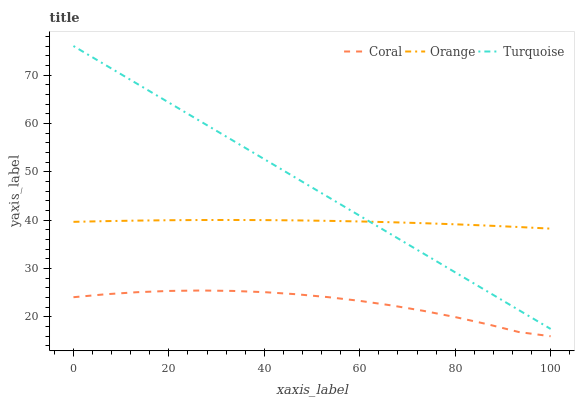Does Coral have the minimum area under the curve?
Answer yes or no. Yes. Does Turquoise have the maximum area under the curve?
Answer yes or no. Yes. Does Turquoise have the minimum area under the curve?
Answer yes or no. No. Does Coral have the maximum area under the curve?
Answer yes or no. No. Is Turquoise the smoothest?
Answer yes or no. Yes. Is Coral the roughest?
Answer yes or no. Yes. Is Coral the smoothest?
Answer yes or no. No. Is Turquoise the roughest?
Answer yes or no. No. Does Turquoise have the lowest value?
Answer yes or no. No. Does Turquoise have the highest value?
Answer yes or no. Yes. Does Coral have the highest value?
Answer yes or no. No. Is Coral less than Turquoise?
Answer yes or no. Yes. Is Orange greater than Coral?
Answer yes or no. Yes. Does Orange intersect Turquoise?
Answer yes or no. Yes. Is Orange less than Turquoise?
Answer yes or no. No. Is Orange greater than Turquoise?
Answer yes or no. No. Does Coral intersect Turquoise?
Answer yes or no. No. 